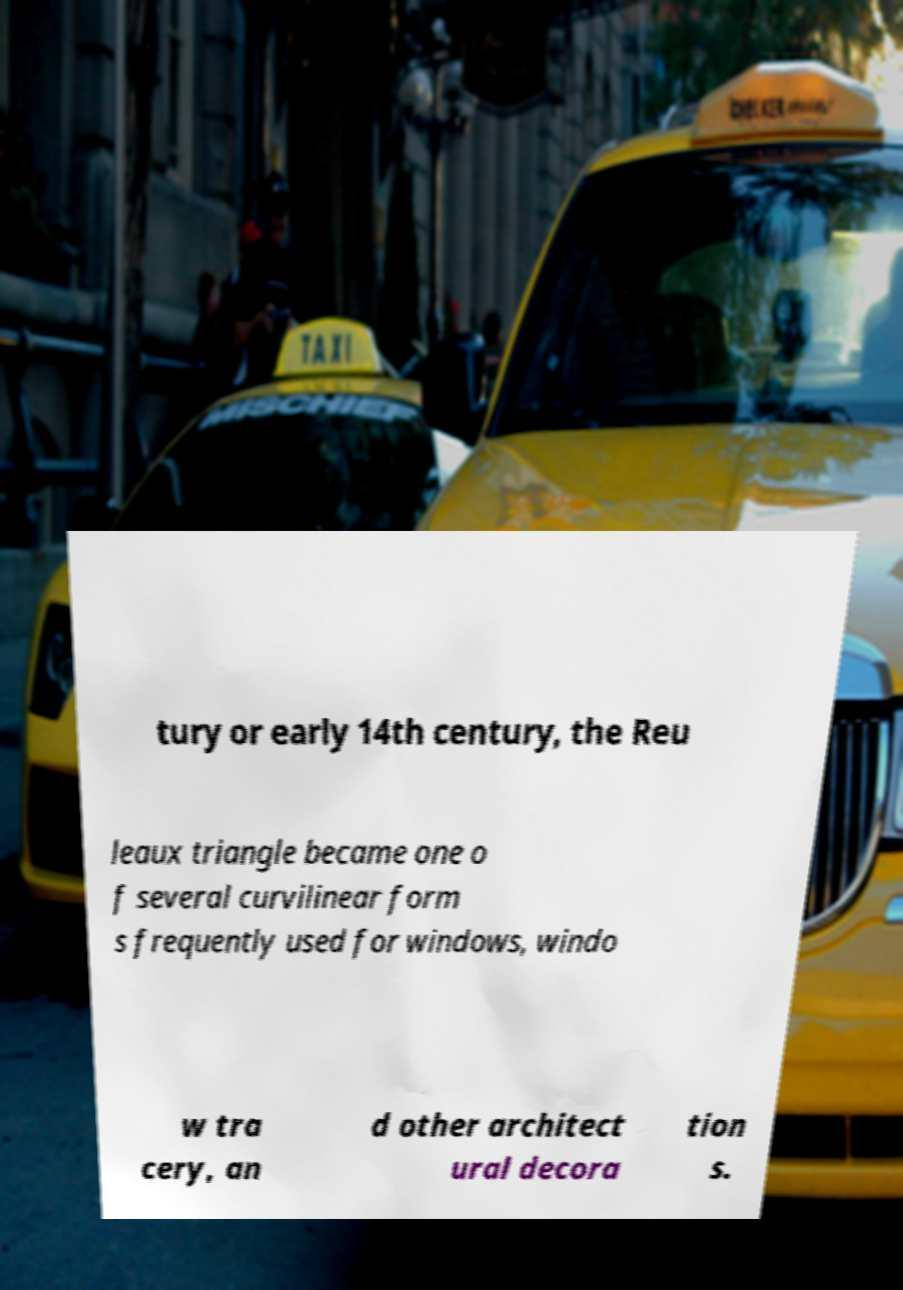There's text embedded in this image that I need extracted. Can you transcribe it verbatim? tury or early 14th century, the Reu leaux triangle became one o f several curvilinear form s frequently used for windows, windo w tra cery, an d other architect ural decora tion s. 